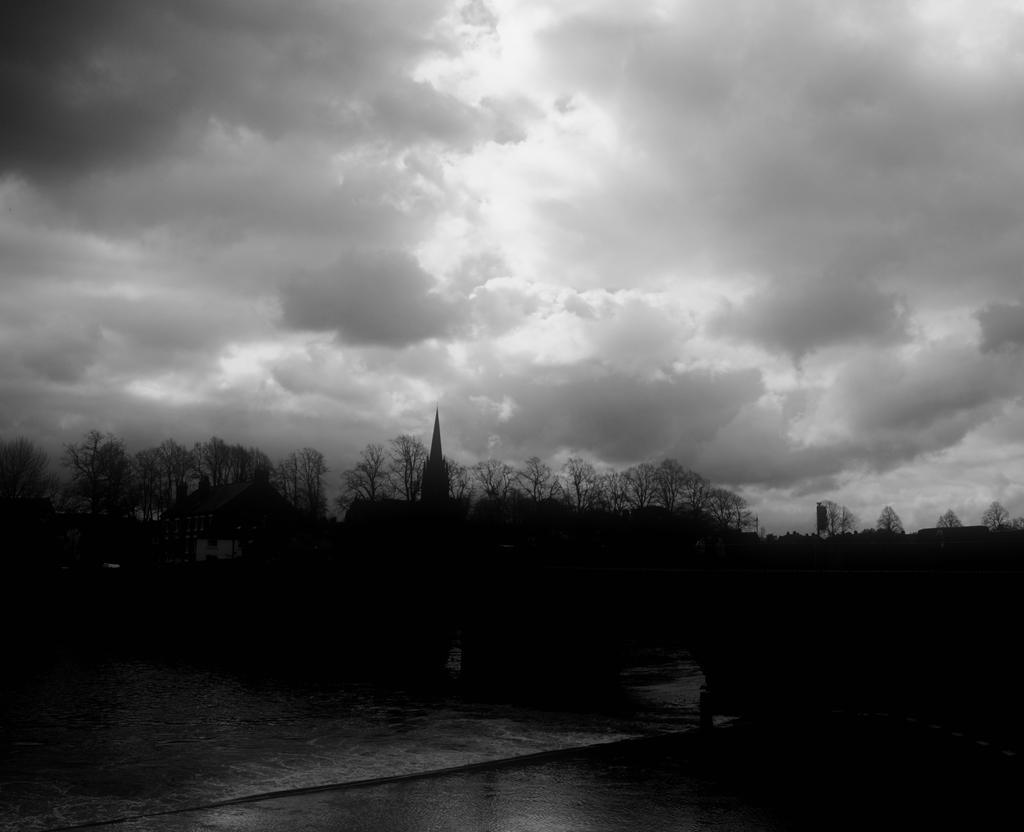In one or two sentences, can you explain what this image depicts? In this image we can see trees, here is the water, at above the sky is cloudy. 